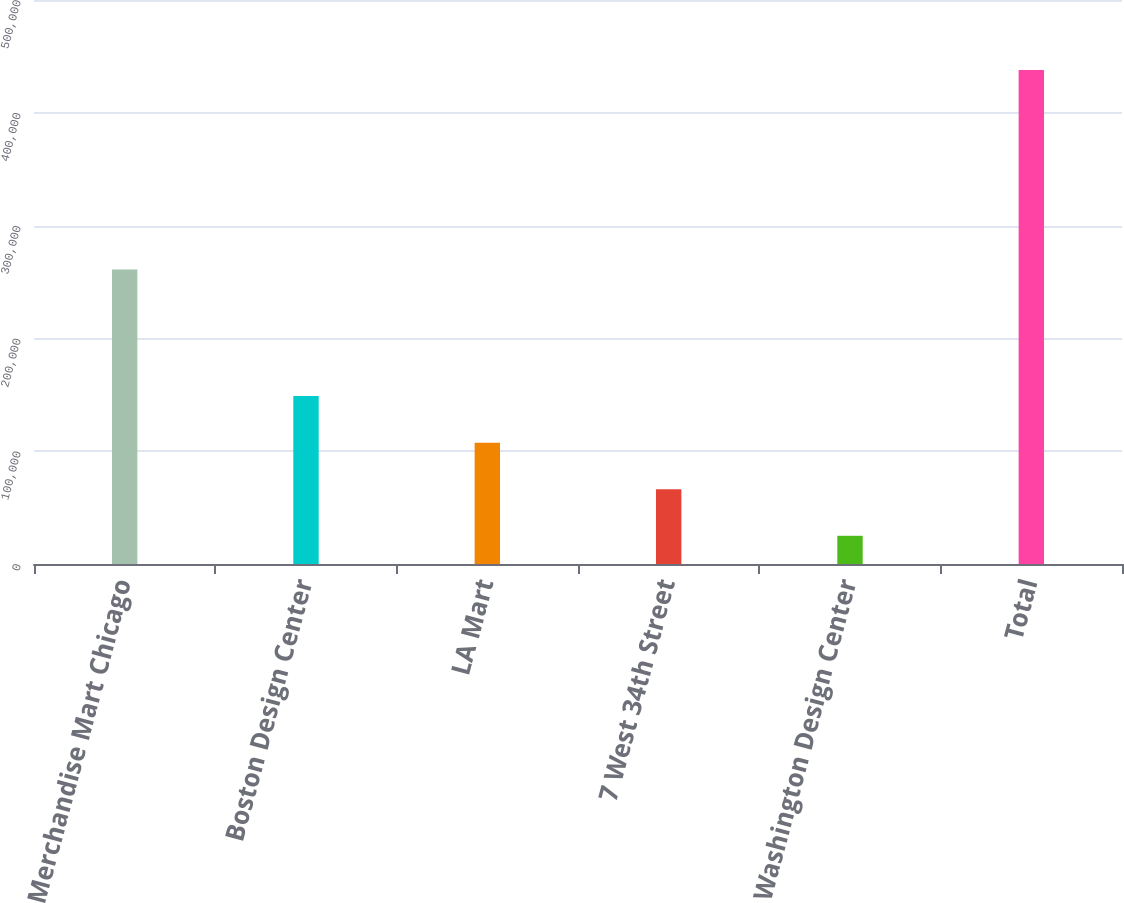<chart> <loc_0><loc_0><loc_500><loc_500><bar_chart><fcel>Merchandise Mart Chicago<fcel>Boston Design Center<fcel>LA Mart<fcel>7 West 34th Street<fcel>Washington Design Center<fcel>Total<nl><fcel>261000<fcel>148900<fcel>107600<fcel>66300<fcel>25000<fcel>438000<nl></chart> 